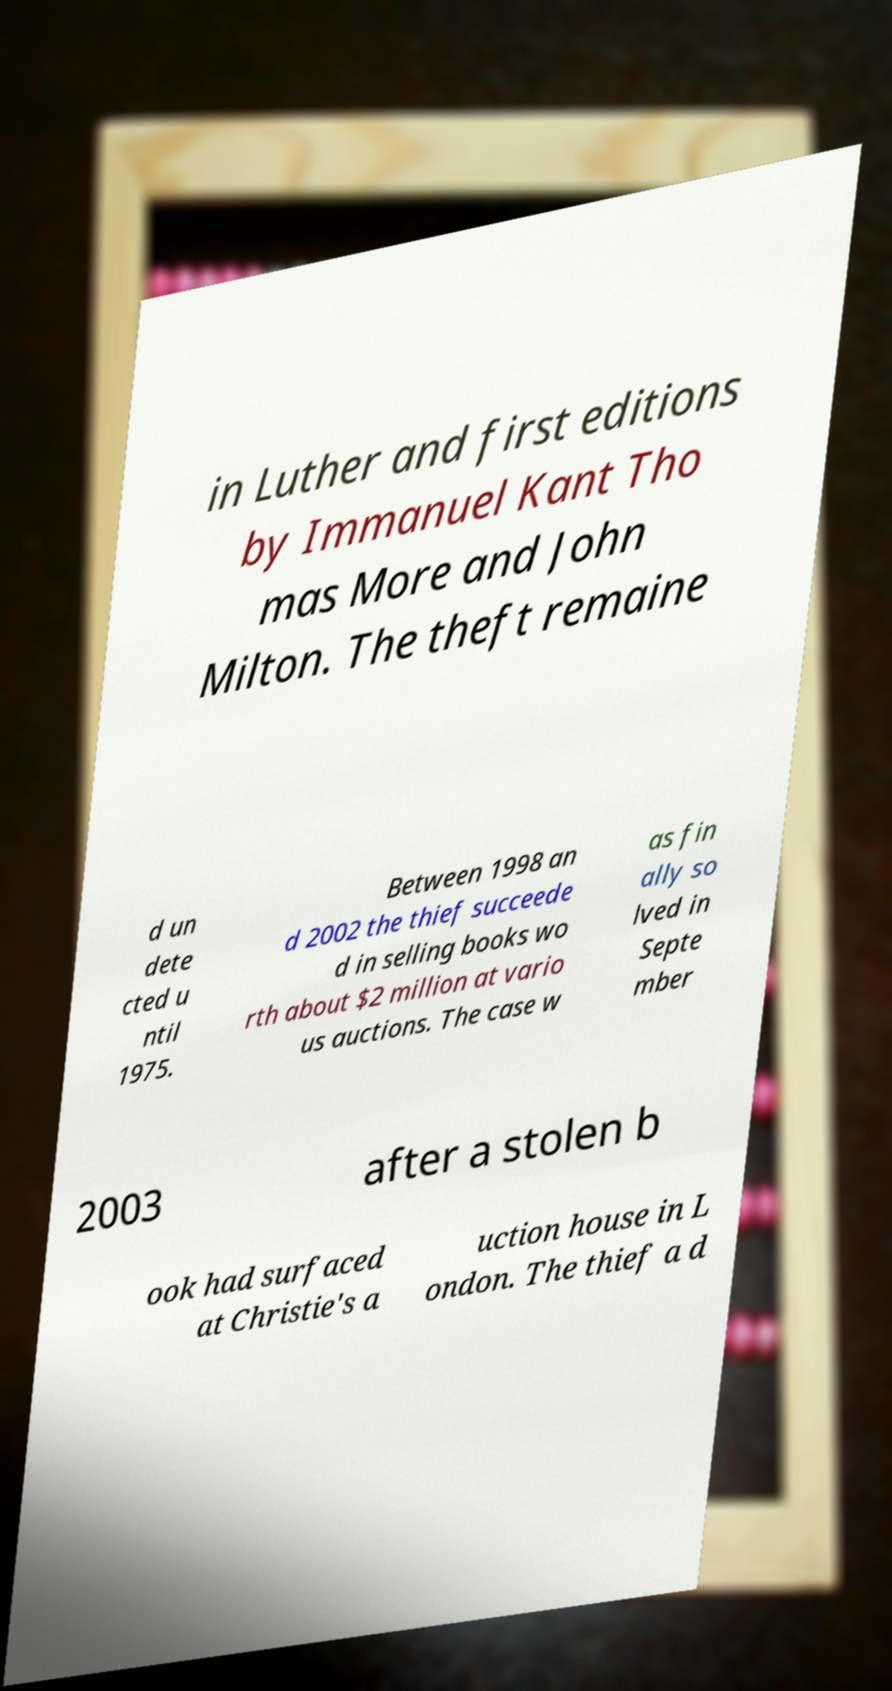Can you read and provide the text displayed in the image?This photo seems to have some interesting text. Can you extract and type it out for me? in Luther and first editions by Immanuel Kant Tho mas More and John Milton. The theft remaine d un dete cted u ntil 1975. Between 1998 an d 2002 the thief succeede d in selling books wo rth about $2 million at vario us auctions. The case w as fin ally so lved in Septe mber 2003 after a stolen b ook had surfaced at Christie's a uction house in L ondon. The thief a d 